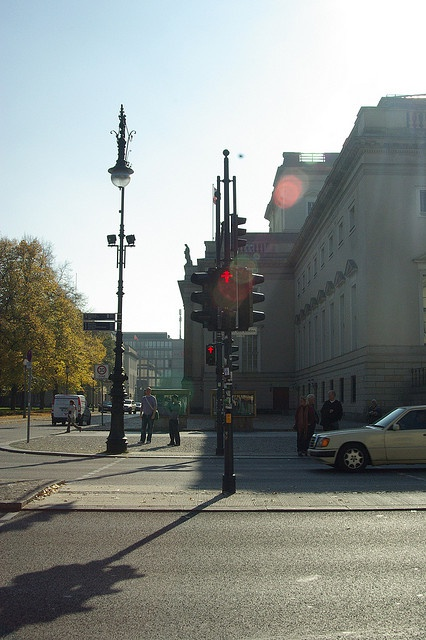Describe the objects in this image and their specific colors. I can see car in lightblue, black, and gray tones, traffic light in lightblue, black, gray, and purple tones, traffic light in lightblue, black, maroon, and gray tones, traffic light in lightblue, black, maroon, and red tones, and people in lightblue, black, and gray tones in this image. 